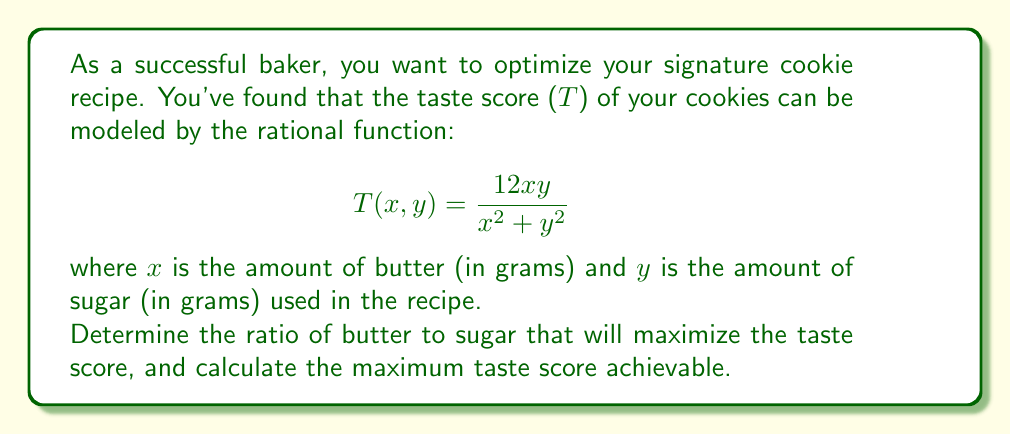What is the answer to this math problem? To find the optimal ratio of butter to sugar, we need to maximize the taste score function T(x,y). Let's approach this step-by-step:

1) First, we can simplify our search by noting that the taste score depends only on the ratio of x to y, not their absolute values. Let's set y = kx, where k is the ratio of sugar to butter.

2) Substituting this into our original function:

   $$T(x, kx) = \frac{12x(kx)}{x^2 + (kx)^2} = \frac{12kx^2}{x^2(1+k^2)} = \frac{12k}{1+k^2}$$

3) Now we have a function of k only. To find the maximum, we can differentiate with respect to k and set it to zero:

   $$\frac{d}{dk}\left(\frac{12k}{1+k^2}\right) = \frac{12(1+k^2) - 12k(2k)}{(1+k^2)^2} = \frac{12-12k^2}{(1+k^2)^2} = 0$$

4) Solving this equation:

   $12 - 12k^2 = 0$
   $12k^2 = 12$
   $k^2 = 1$
   $k = 1$ (we take the positive root as we're dealing with quantities)

5) This means the optimal ratio of sugar to butter is 1:1, or in other words, equal amounts of butter and sugar.

6) To find the maximum taste score, we substitute k = 1 back into our simplified function:

   $$T_{max} = \frac{12(1)}{1+1^2} = \frac{12}{2} = 6$$

Therefore, the maximum taste score achievable is 6.
Answer: 1:1 ratio of butter to sugar; maximum taste score of 6 